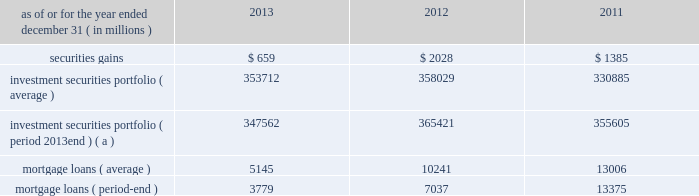Management 2019s discussion and analysis 110 jpmorgan chase & co./2013 annual report 2012 compared with 2011 net loss was $ 2.0 billion , compared with a net income of $ 919 million in the prior year .
Private equity reported net income of $ 292 million , compared with net income of $ 391 million in the prior year .
Net revenue was $ 601 million , compared with $ 836 million in the prior year , due to lower unrealized and realized gains on private investments , partially offset by higher unrealized gains on public securities .
Noninterest expense was $ 145 million , down from $ 238 million in the prior year .
Treasury and cio reported a net loss of $ 2.1 billion , compared with net income of $ 1.3 billion in the prior year .
Net revenue was a loss of $ 3.1 billion , compared with net revenue of $ 3.2 billion in the prior year .
The current year loss reflected $ 5.8 billion of losses incurred by cio from the synthetic credit portfolio for the six months ended june 30 , 2012 , and $ 449 million of losses from the retained index credit derivative positions for the three months ended september 30 , 2012 .
These losses were partially offset by securities gains of $ 2.0 billion .
The current year revenue reflected $ 888 million of extinguishment gains related to the redemption of trust preferred securities , which are included in all other income in the above table .
The extinguishment gains were related to adjustments applied to the cost basis of the trust preferred securities during the period they were in a qualified hedge accounting relationship .
Net interest income was negative $ 683 million , compared with $ 1.4 billion in the prior year , primarily reflecting the impact of lower portfolio yields and higher deposit balances across the firm .
Other corporate reported a net loss of $ 221 million , compared with a net loss of $ 821 million in the prior year .
Noninterest revenue of $ 1.8 billion was driven by a $ 1.1 billion benefit for the washington mutual bankruptcy settlement , which is included in all other income in the above table , and a $ 665 million gain from the recovery on a bear stearns-related subordinated loan .
Noninterest expense of $ 3.8 billion was up $ 1.0 billion compared with the prior year .
The current year included expense of $ 3.7 billion for additional litigation reserves , largely for mortgage-related matters .
The prior year included expense of $ 3.2 billion for additional litigation reserves .
Treasury and cio overview treasury and cio are predominantly responsible for measuring , monitoring , reporting and managing the firm 2019s liquidity , funding and structural interest rate and foreign exchange risks , as well as executing the firm 2019s capital plan .
The risks managed by treasury and cio arise from the activities undertaken by the firm 2019s four major reportable business segments to serve their respective client bases , which generate both on- and off-balance sheet assets and liabilities .
Cio achieves the firm 2019s asset-liability management objectives generally by investing in high-quality securities that are managed for the longer-term as part of the firm 2019s afs and htm investment securities portfolios ( the 201cinvestment securities portfolio 201d ) .
Cio also uses derivatives , as well as securities that are not classified as afs or htm , to meet the firm 2019s asset-liability management objectives .
For further information on derivatives , see note 6 on pages 220 2013233 of this annual report .
For further information about securities not classified within the afs or htm portfolio , see note 3 on pages 195 2013215 of this annual report .
The treasury and cio investment securities portfolio primarily consists of u.s .
And non-u.s .
Government securities , agency and non-agency mortgage-backed securities , other asset-backed securities , corporate debt securities and obligations of u.s .
States and municipalities .
At december 31 , 2013 , the total treasury and cio investment securities portfolio was $ 347.6 billion ; the average credit rating of the securities comprising the treasury and cio investment securities portfolio was aa+ ( based upon external ratings where available and where not available , based primarily upon internal ratings that correspond to ratings as defined by s&p and moody 2019s ) .
See note 12 on pages 249 2013254 of this annual report for further information on the details of the firm 2019s investment securities portfolio .
For further information on liquidity and funding risk , see liquidity risk management on pages 168 2013173 of this annual report .
For information on interest rate , foreign exchange and other risks , treasury and cio value-at-risk ( 201cvar 201d ) and the firm 2019s structural interest rate-sensitive revenue at risk , see market risk management on pages 142 2013148 of this annual report .
Selected income statement and balance sheet data as of or for the year ended december 31 , ( in millions ) 2013 2012 2011 .
( a ) period-end investment securities included held-to-maturity balance of $ 24.0 billion at december 31 , 2013 .
Held-to-maturity balances for the other periods were not material. .
What was the percentage increase in litigation reserves in 2012? 
Computations: ((3.7 - 3.2) / 3.2)
Answer: 0.15625. 